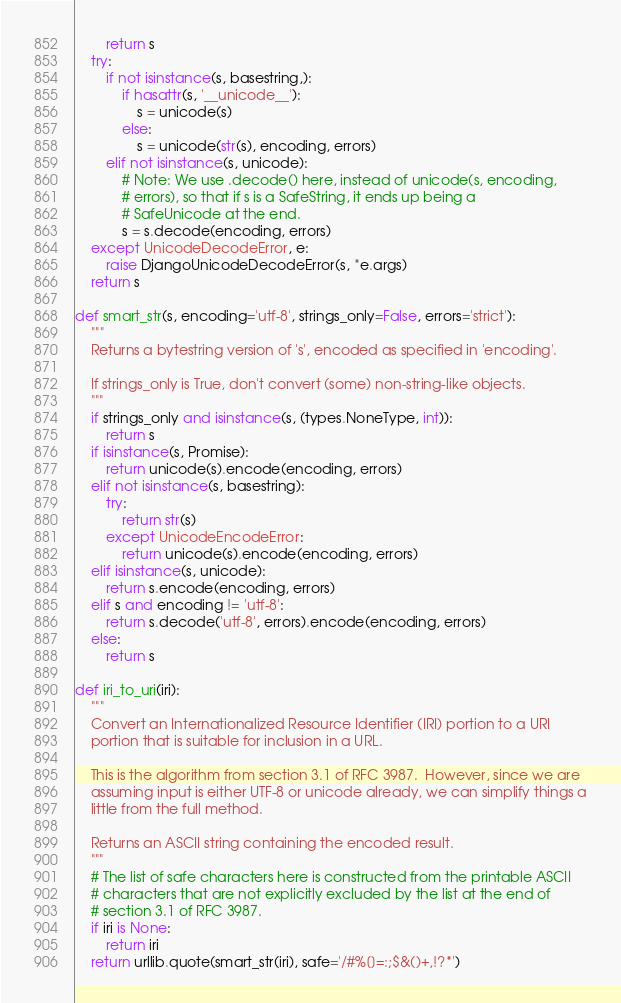Convert code to text. <code><loc_0><loc_0><loc_500><loc_500><_Python_>        return s
    try:
        if not isinstance(s, basestring,):
            if hasattr(s, '__unicode__'):
                s = unicode(s)
            else:
                s = unicode(str(s), encoding, errors)
        elif not isinstance(s, unicode):
            # Note: We use .decode() here, instead of unicode(s, encoding,
            # errors), so that if s is a SafeString, it ends up being a
            # SafeUnicode at the end.
            s = s.decode(encoding, errors)
    except UnicodeDecodeError, e:
        raise DjangoUnicodeDecodeError(s, *e.args)
    return s

def smart_str(s, encoding='utf-8', strings_only=False, errors='strict'):
    """
    Returns a bytestring version of 's', encoded as specified in 'encoding'.

    If strings_only is True, don't convert (some) non-string-like objects.
    """
    if strings_only and isinstance(s, (types.NoneType, int)):
        return s
    if isinstance(s, Promise):
        return unicode(s).encode(encoding, errors)
    elif not isinstance(s, basestring):
        try:
            return str(s)
        except UnicodeEncodeError:
            return unicode(s).encode(encoding, errors)
    elif isinstance(s, unicode):
        return s.encode(encoding, errors)
    elif s and encoding != 'utf-8':
        return s.decode('utf-8', errors).encode(encoding, errors)
    else:
        return s

def iri_to_uri(iri):
    """
    Convert an Internationalized Resource Identifier (IRI) portion to a URI
    portion that is suitable for inclusion in a URL.

    This is the algorithm from section 3.1 of RFC 3987.  However, since we are
    assuming input is either UTF-8 or unicode already, we can simplify things a
    little from the full method.

    Returns an ASCII string containing the encoded result.
    """
    # The list of safe characters here is constructed from the printable ASCII
    # characters that are not explicitly excluded by the list at the end of
    # section 3.1 of RFC 3987.
    if iri is None:
        return iri
    return urllib.quote(smart_str(iri), safe='/#%[]=:;$&()+,!?*')

</code> 